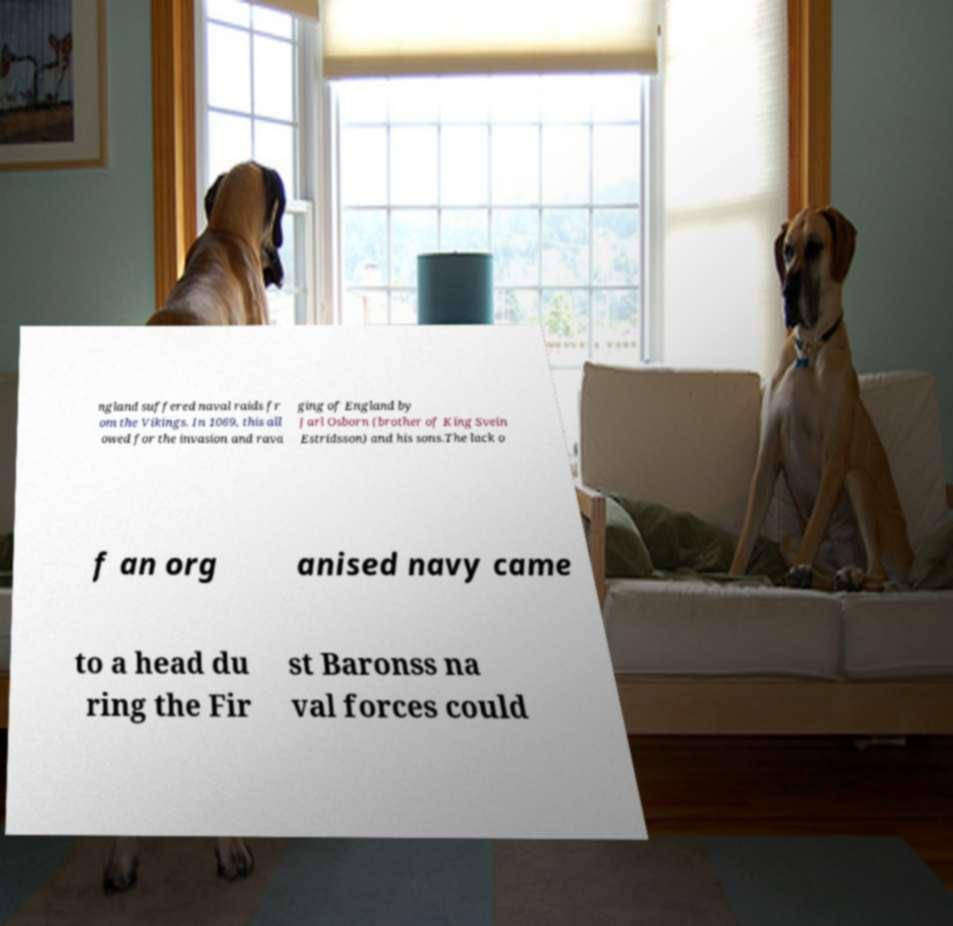Could you extract and type out the text from this image? ngland suffered naval raids fr om the Vikings. In 1069, this all owed for the invasion and rava ging of England by Jarl Osborn (brother of King Svein Estridsson) and his sons.The lack o f an org anised navy came to a head du ring the Fir st Baronss na val forces could 